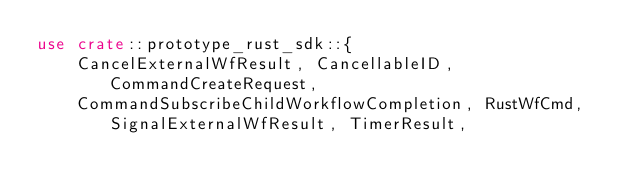<code> <loc_0><loc_0><loc_500><loc_500><_Rust_>use crate::prototype_rust_sdk::{
    CancelExternalWfResult, CancellableID, CommandCreateRequest,
    CommandSubscribeChildWorkflowCompletion, RustWfCmd, SignalExternalWfResult, TimerResult,</code> 